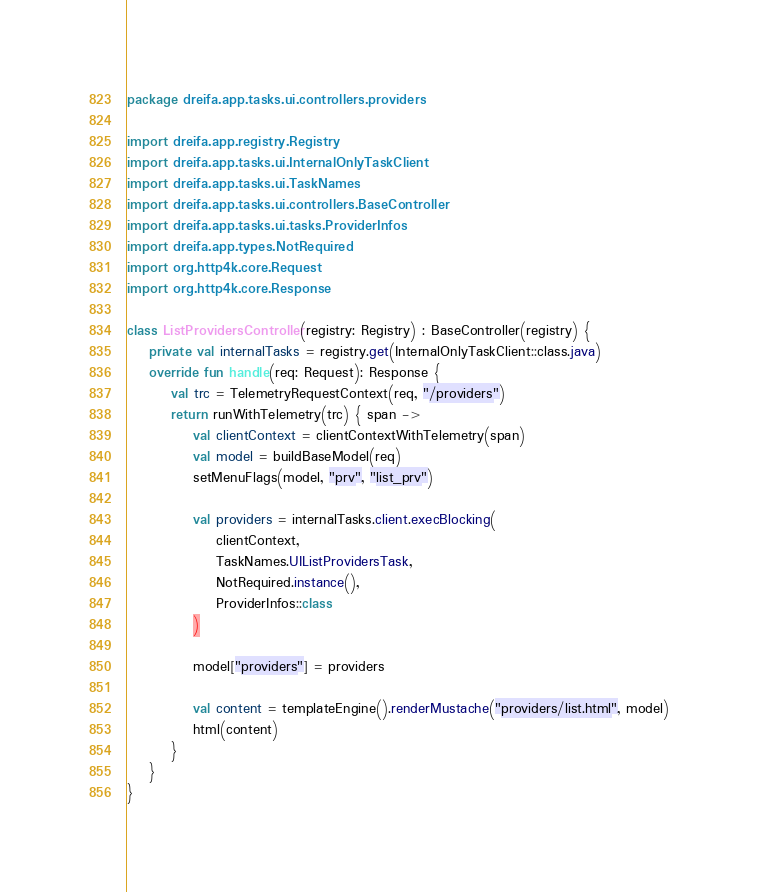<code> <loc_0><loc_0><loc_500><loc_500><_Kotlin_>package dreifa.app.tasks.ui.controllers.providers

import dreifa.app.registry.Registry
import dreifa.app.tasks.ui.InternalOnlyTaskClient
import dreifa.app.tasks.ui.TaskNames
import dreifa.app.tasks.ui.controllers.BaseController
import dreifa.app.tasks.ui.tasks.ProviderInfos
import dreifa.app.types.NotRequired
import org.http4k.core.Request
import org.http4k.core.Response

class ListProvidersController(registry: Registry) : BaseController(registry) {
    private val internalTasks = registry.get(InternalOnlyTaskClient::class.java)
    override fun handle(req: Request): Response {
        val trc = TelemetryRequestContext(req, "/providers")
        return runWithTelemetry(trc) { span ->
            val clientContext = clientContextWithTelemetry(span)
            val model = buildBaseModel(req)
            setMenuFlags(model, "prv", "list_prv")

            val providers = internalTasks.client.execBlocking(
                clientContext,
                TaskNames.UIListProvidersTask,
                NotRequired.instance(),
                ProviderInfos::class
            )

            model["providers"] = providers

            val content = templateEngine().renderMustache("providers/list.html", model)
            html(content)
        }
    }
}</code> 